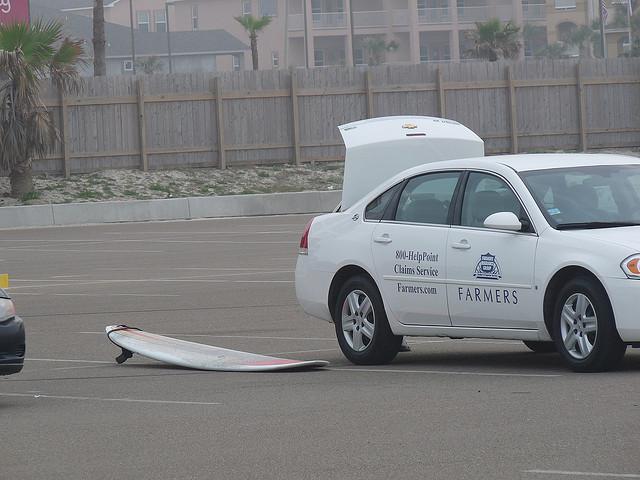Is the car parked?
Concise answer only. Yes. Is there a car parked at the curb?
Be succinct. No. How many lines are on the ground?
Write a very short answer. 10. Is the road asphalt?
Answer briefly. Yes. Is there a surfboard parked in the parking lot?
Concise answer only. Yes. What business owns the car?
Quick response, please. Farmers insurance. What color is the car?
Short answer required. White. 